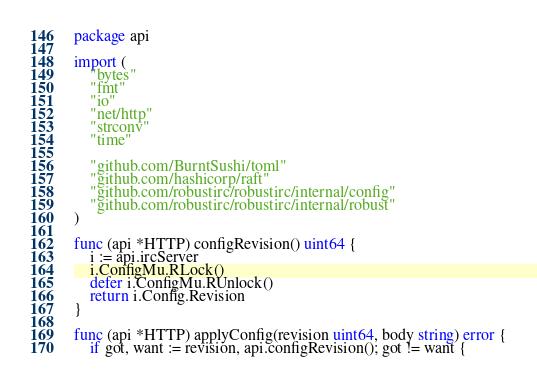Convert code to text. <code><loc_0><loc_0><loc_500><loc_500><_Go_>package api

import (
	"bytes"
	"fmt"
	"io"
	"net/http"
	"strconv"
	"time"

	"github.com/BurntSushi/toml"
	"github.com/hashicorp/raft"
	"github.com/robustirc/robustirc/internal/config"
	"github.com/robustirc/robustirc/internal/robust"
)

func (api *HTTP) configRevision() uint64 {
	i := api.ircServer
	i.ConfigMu.RLock()
	defer i.ConfigMu.RUnlock()
	return i.Config.Revision
}

func (api *HTTP) applyConfig(revision uint64, body string) error {
	if got, want := revision, api.configRevision(); got != want {</code> 